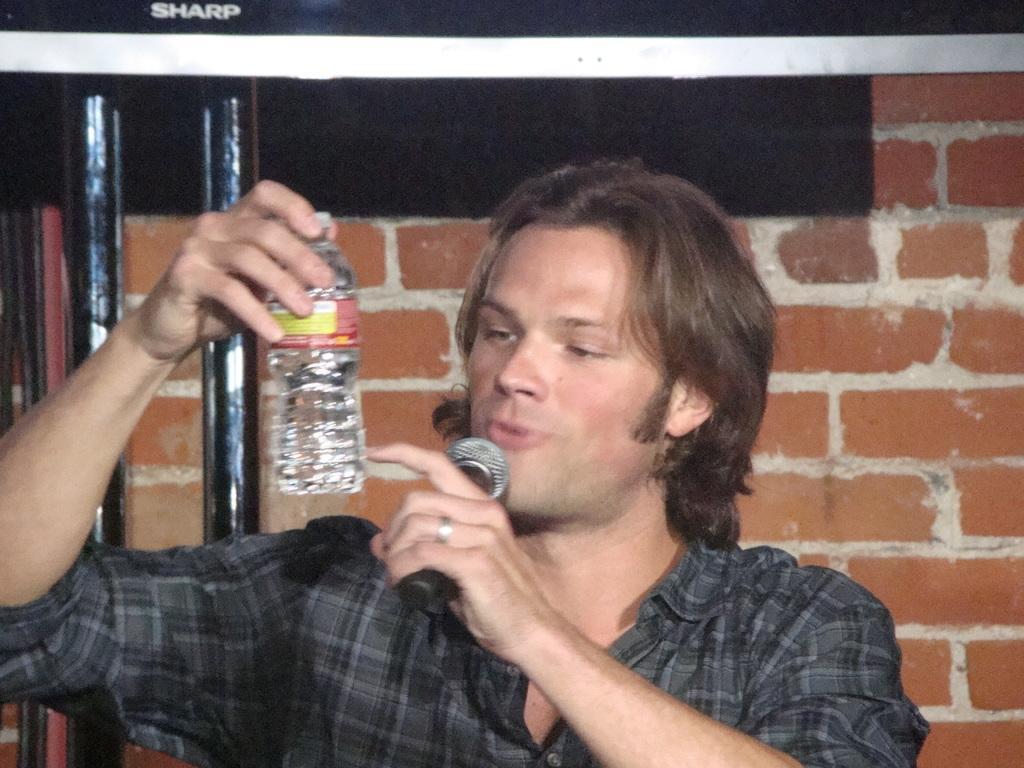How would you summarize this image in a sentence or two? There is a man who is holding a mike with one hand and bottle with another hand. And this is wall. 